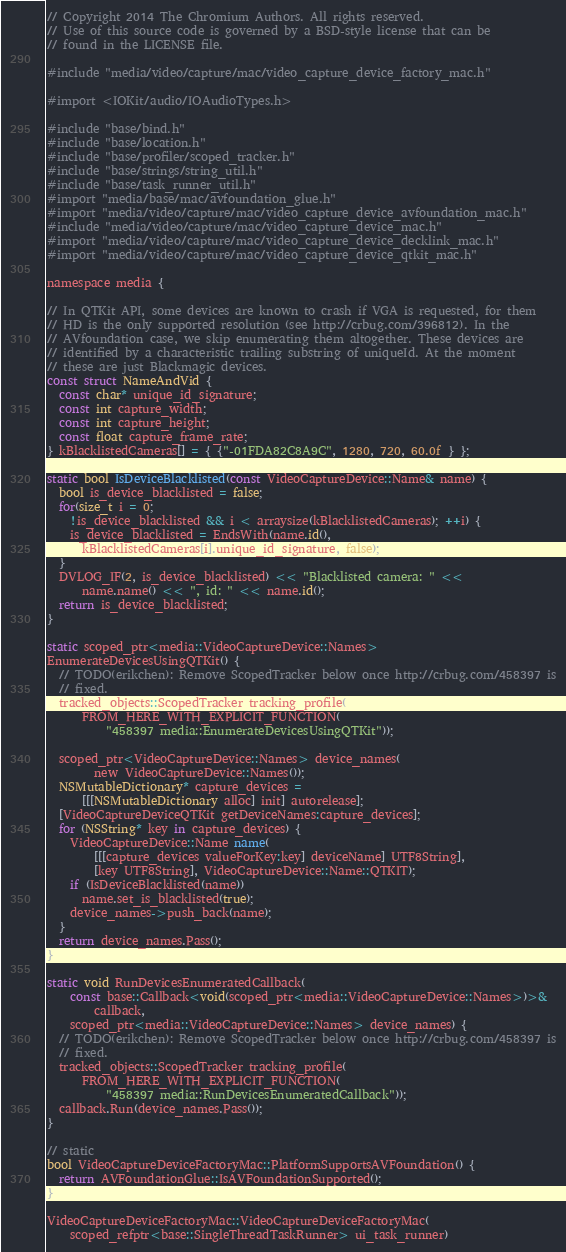Convert code to text. <code><loc_0><loc_0><loc_500><loc_500><_ObjectiveC_>// Copyright 2014 The Chromium Authors. All rights reserved.
// Use of this source code is governed by a BSD-style license that can be
// found in the LICENSE file.

#include "media/video/capture/mac/video_capture_device_factory_mac.h"

#import <IOKit/audio/IOAudioTypes.h>

#include "base/bind.h"
#include "base/location.h"
#include "base/profiler/scoped_tracker.h"
#include "base/strings/string_util.h"
#include "base/task_runner_util.h"
#import "media/base/mac/avfoundation_glue.h"
#import "media/video/capture/mac/video_capture_device_avfoundation_mac.h"
#include "media/video/capture/mac/video_capture_device_mac.h"
#import "media/video/capture/mac/video_capture_device_decklink_mac.h"
#import "media/video/capture/mac/video_capture_device_qtkit_mac.h"

namespace media {

// In QTKit API, some devices are known to crash if VGA is requested, for them
// HD is the only supported resolution (see http://crbug.com/396812). In the
// AVfoundation case, we skip enumerating them altogether. These devices are
// identified by a characteristic trailing substring of uniqueId. At the moment
// these are just Blackmagic devices.
const struct NameAndVid {
  const char* unique_id_signature;
  const int capture_width;
  const int capture_height;
  const float capture_frame_rate;
} kBlacklistedCameras[] = { {"-01FDA82C8A9C", 1280, 720, 60.0f } };

static bool IsDeviceBlacklisted(const VideoCaptureDevice::Name& name) {
  bool is_device_blacklisted = false;
  for(size_t i = 0;
    !is_device_blacklisted && i < arraysize(kBlacklistedCameras); ++i) {
    is_device_blacklisted = EndsWith(name.id(),
      kBlacklistedCameras[i].unique_id_signature, false);
  }
  DVLOG_IF(2, is_device_blacklisted) << "Blacklisted camera: " <<
      name.name() << ", id: " << name.id();
  return is_device_blacklisted;
}

static scoped_ptr<media::VideoCaptureDevice::Names>
EnumerateDevicesUsingQTKit() {
  // TODO(erikchen): Remove ScopedTracker below once http://crbug.com/458397 is
  // fixed.
  tracked_objects::ScopedTracker tracking_profile(
      FROM_HERE_WITH_EXPLICIT_FUNCTION(
          "458397 media::EnumerateDevicesUsingQTKit"));

  scoped_ptr<VideoCaptureDevice::Names> device_names(
        new VideoCaptureDevice::Names());
  NSMutableDictionary* capture_devices =
      [[[NSMutableDictionary alloc] init] autorelease];
  [VideoCaptureDeviceQTKit getDeviceNames:capture_devices];
  for (NSString* key in capture_devices) {
    VideoCaptureDevice::Name name(
        [[[capture_devices valueForKey:key] deviceName] UTF8String],
        [key UTF8String], VideoCaptureDevice::Name::QTKIT);
    if (IsDeviceBlacklisted(name))
      name.set_is_blacklisted(true);
    device_names->push_back(name);
  }
  return device_names.Pass();
}

static void RunDevicesEnumeratedCallback(
    const base::Callback<void(scoped_ptr<media::VideoCaptureDevice::Names>)>&
        callback,
    scoped_ptr<media::VideoCaptureDevice::Names> device_names) {
  // TODO(erikchen): Remove ScopedTracker below once http://crbug.com/458397 is
  // fixed.
  tracked_objects::ScopedTracker tracking_profile(
      FROM_HERE_WITH_EXPLICIT_FUNCTION(
          "458397 media::RunDevicesEnumeratedCallback"));
  callback.Run(device_names.Pass());
}

// static
bool VideoCaptureDeviceFactoryMac::PlatformSupportsAVFoundation() {
  return AVFoundationGlue::IsAVFoundationSupported();
}

VideoCaptureDeviceFactoryMac::VideoCaptureDeviceFactoryMac(
    scoped_refptr<base::SingleThreadTaskRunner> ui_task_runner)</code> 